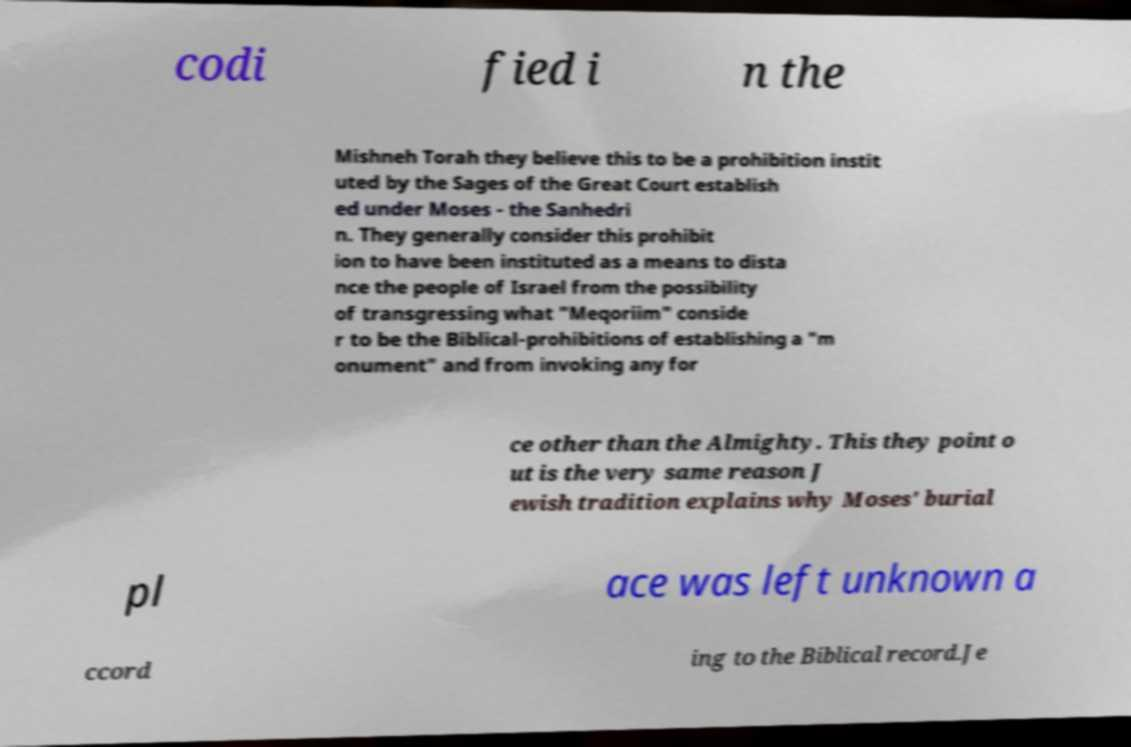I need the written content from this picture converted into text. Can you do that? codi fied i n the Mishneh Torah they believe this to be a prohibition instit uted by the Sages of the Great Court establish ed under Moses - the Sanhedri n. They generally consider this prohibit ion to have been instituted as a means to dista nce the people of Israel from the possibility of transgressing what "Meqoriim" conside r to be the Biblical-prohibitions of establishing a "m onument" and from invoking any for ce other than the Almighty. This they point o ut is the very same reason J ewish tradition explains why Moses' burial pl ace was left unknown a ccord ing to the Biblical record.Je 